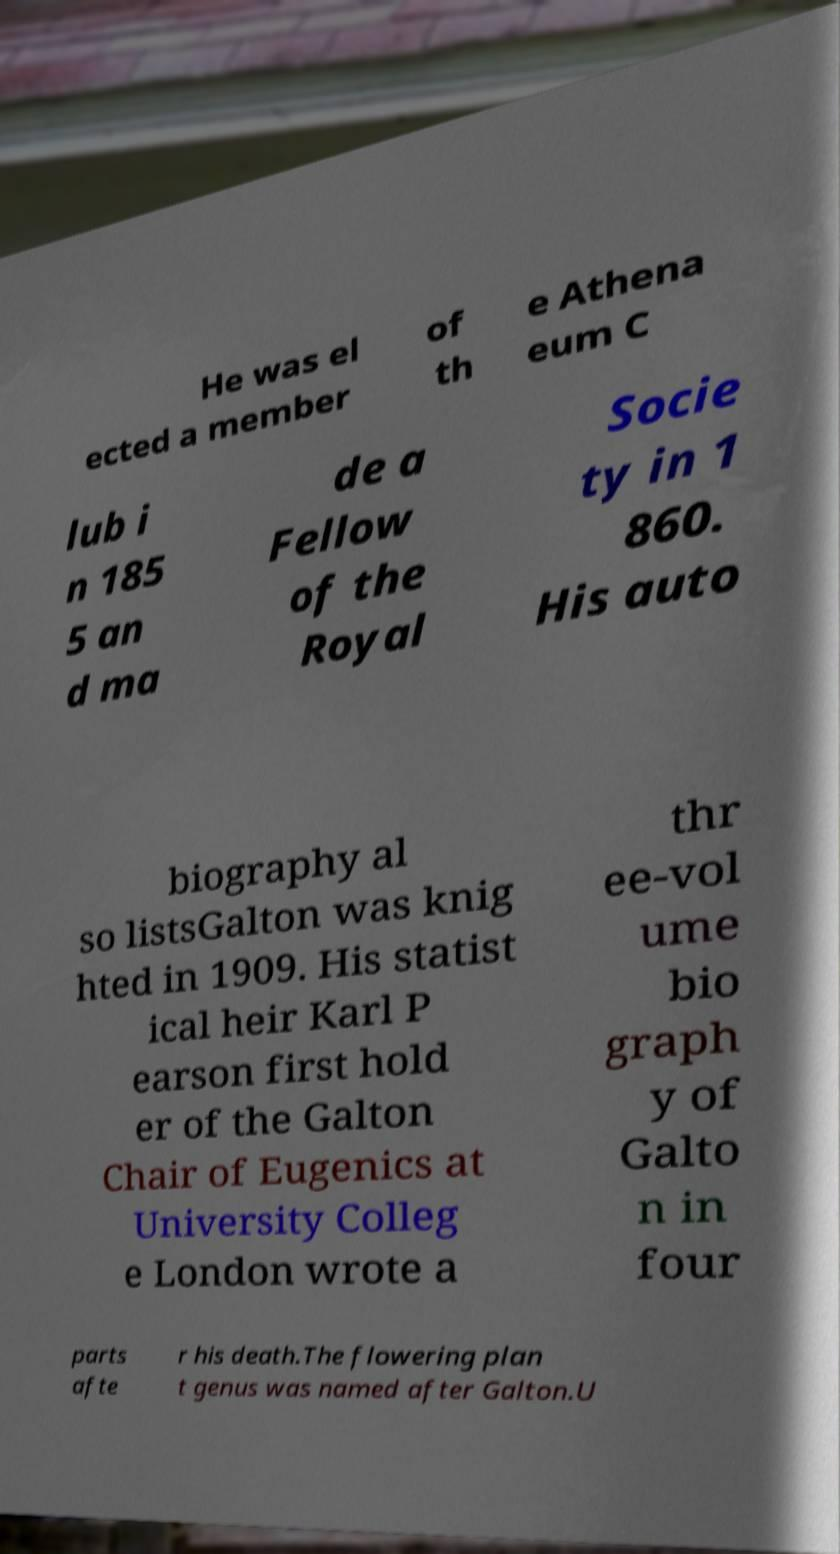What messages or text are displayed in this image? I need them in a readable, typed format. He was el ected a member of th e Athena eum C lub i n 185 5 an d ma de a Fellow of the Royal Socie ty in 1 860. His auto biography al so listsGalton was knig hted in 1909. His statist ical heir Karl P earson first hold er of the Galton Chair of Eugenics at University Colleg e London wrote a thr ee-vol ume bio graph y of Galto n in four parts afte r his death.The flowering plan t genus was named after Galton.U 